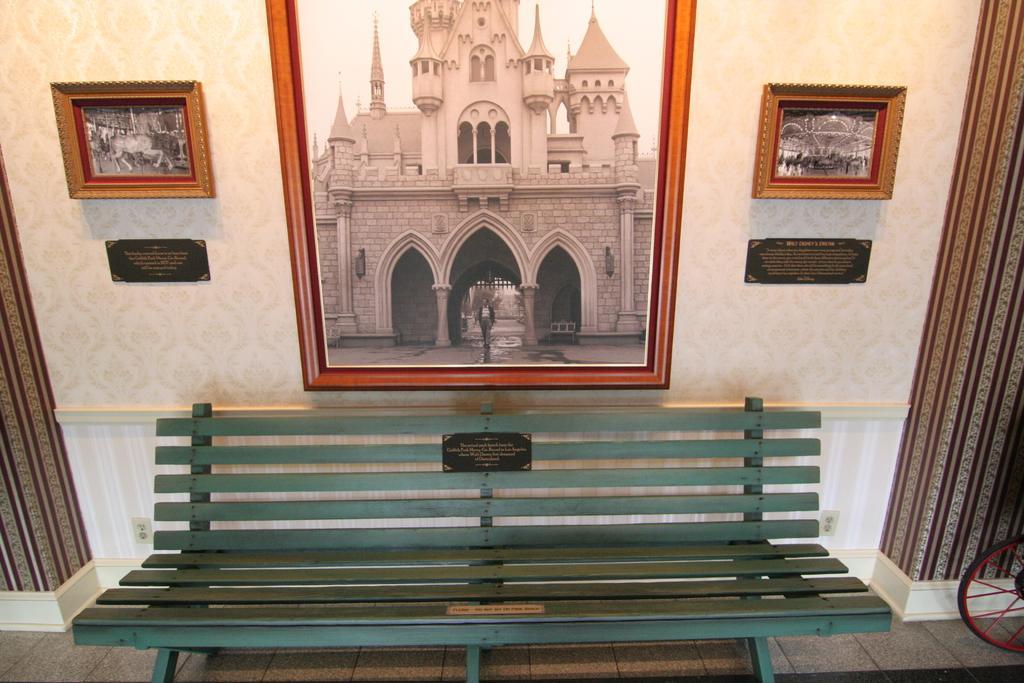Please provide a concise description of this image. In this picture we can see a bench on the path. There are few pillars and frames on the wall. We can see a wheel on the left side. 